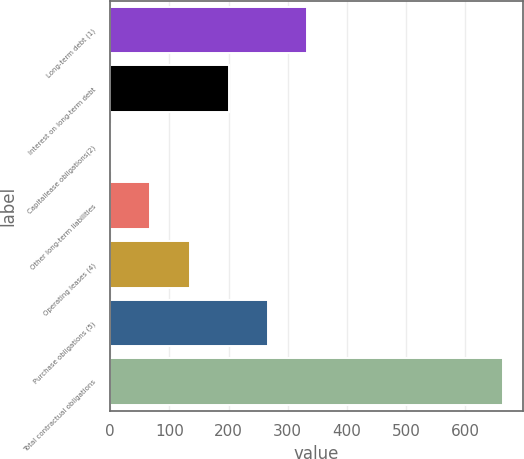<chart> <loc_0><loc_0><loc_500><loc_500><bar_chart><fcel>Long-term debt (1)<fcel>Interest on long-term debt<fcel>Capitallease obligations(2)<fcel>Other long-term liabilities<fcel>Operating leases (4)<fcel>Purchase obligations (5)<fcel>Total contractual obligations<nl><fcel>333.1<fcel>200.58<fcel>1.8<fcel>68.06<fcel>134.32<fcel>266.84<fcel>664.4<nl></chart> 